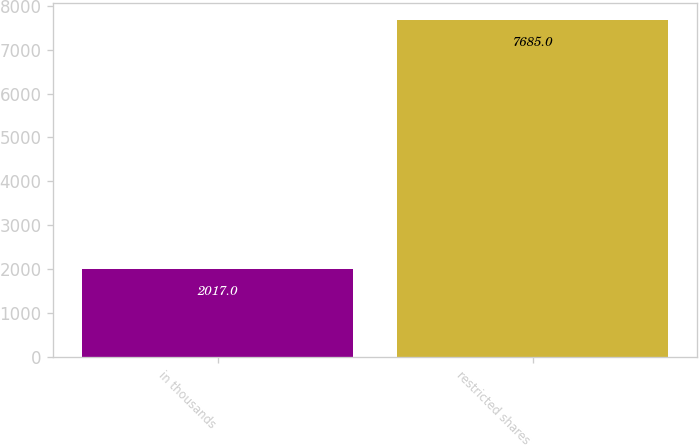Convert chart. <chart><loc_0><loc_0><loc_500><loc_500><bar_chart><fcel>in thousands<fcel>restricted shares<nl><fcel>2017<fcel>7685<nl></chart> 